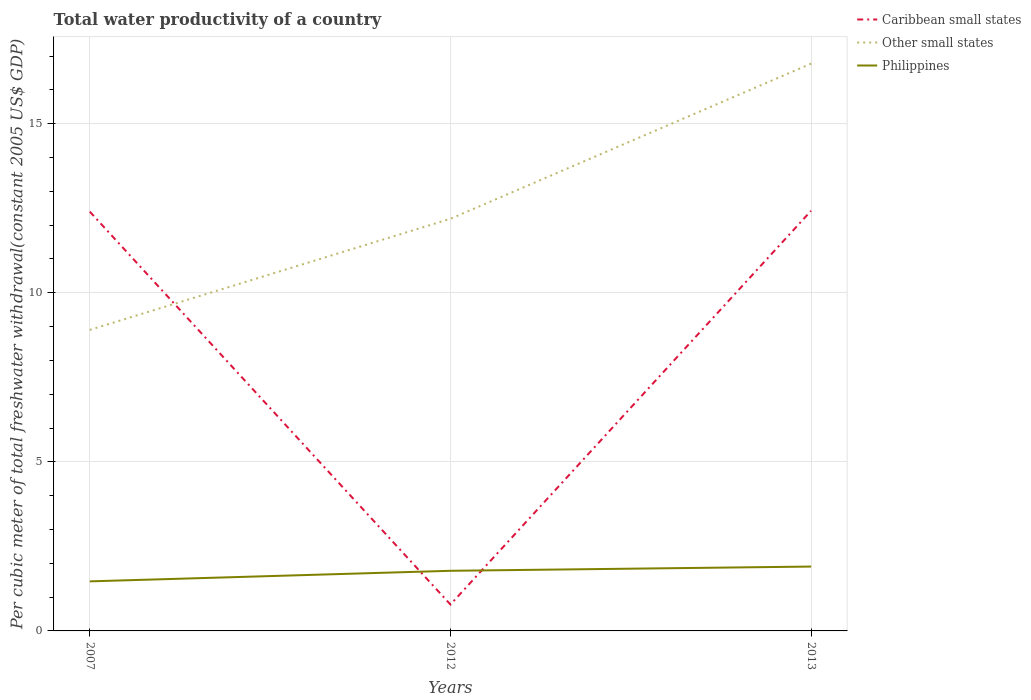How many different coloured lines are there?
Offer a very short reply. 3. Across all years, what is the maximum total water productivity in Other small states?
Your answer should be very brief. 8.9. What is the total total water productivity in Other small states in the graph?
Provide a short and direct response. -4.59. What is the difference between the highest and the second highest total water productivity in Other small states?
Provide a succinct answer. 7.87. Is the total water productivity in Caribbean small states strictly greater than the total water productivity in Philippines over the years?
Your answer should be very brief. No. How many years are there in the graph?
Your response must be concise. 3. Are the values on the major ticks of Y-axis written in scientific E-notation?
Give a very brief answer. No. How many legend labels are there?
Provide a short and direct response. 3. How are the legend labels stacked?
Provide a short and direct response. Vertical. What is the title of the graph?
Keep it short and to the point. Total water productivity of a country. Does "Bahrain" appear as one of the legend labels in the graph?
Your answer should be very brief. No. What is the label or title of the Y-axis?
Your answer should be compact. Per cubic meter of total freshwater withdrawal(constant 2005 US$ GDP). What is the Per cubic meter of total freshwater withdrawal(constant 2005 US$ GDP) in Caribbean small states in 2007?
Give a very brief answer. 12.4. What is the Per cubic meter of total freshwater withdrawal(constant 2005 US$ GDP) in Other small states in 2007?
Your answer should be very brief. 8.9. What is the Per cubic meter of total freshwater withdrawal(constant 2005 US$ GDP) in Philippines in 2007?
Offer a very short reply. 1.47. What is the Per cubic meter of total freshwater withdrawal(constant 2005 US$ GDP) of Caribbean small states in 2012?
Keep it short and to the point. 0.78. What is the Per cubic meter of total freshwater withdrawal(constant 2005 US$ GDP) of Other small states in 2012?
Your response must be concise. 12.19. What is the Per cubic meter of total freshwater withdrawal(constant 2005 US$ GDP) in Philippines in 2012?
Provide a short and direct response. 1.78. What is the Per cubic meter of total freshwater withdrawal(constant 2005 US$ GDP) of Caribbean small states in 2013?
Ensure brevity in your answer.  12.43. What is the Per cubic meter of total freshwater withdrawal(constant 2005 US$ GDP) of Other small states in 2013?
Give a very brief answer. 16.78. What is the Per cubic meter of total freshwater withdrawal(constant 2005 US$ GDP) in Philippines in 2013?
Your answer should be compact. 1.9. Across all years, what is the maximum Per cubic meter of total freshwater withdrawal(constant 2005 US$ GDP) in Caribbean small states?
Ensure brevity in your answer.  12.43. Across all years, what is the maximum Per cubic meter of total freshwater withdrawal(constant 2005 US$ GDP) in Other small states?
Offer a very short reply. 16.78. Across all years, what is the maximum Per cubic meter of total freshwater withdrawal(constant 2005 US$ GDP) in Philippines?
Offer a terse response. 1.9. Across all years, what is the minimum Per cubic meter of total freshwater withdrawal(constant 2005 US$ GDP) of Caribbean small states?
Provide a short and direct response. 0.78. Across all years, what is the minimum Per cubic meter of total freshwater withdrawal(constant 2005 US$ GDP) of Other small states?
Your answer should be very brief. 8.9. Across all years, what is the minimum Per cubic meter of total freshwater withdrawal(constant 2005 US$ GDP) of Philippines?
Make the answer very short. 1.47. What is the total Per cubic meter of total freshwater withdrawal(constant 2005 US$ GDP) of Caribbean small states in the graph?
Provide a short and direct response. 25.61. What is the total Per cubic meter of total freshwater withdrawal(constant 2005 US$ GDP) in Other small states in the graph?
Keep it short and to the point. 37.87. What is the total Per cubic meter of total freshwater withdrawal(constant 2005 US$ GDP) of Philippines in the graph?
Your answer should be compact. 5.15. What is the difference between the Per cubic meter of total freshwater withdrawal(constant 2005 US$ GDP) in Caribbean small states in 2007 and that in 2012?
Make the answer very short. 11.62. What is the difference between the Per cubic meter of total freshwater withdrawal(constant 2005 US$ GDP) of Other small states in 2007 and that in 2012?
Keep it short and to the point. -3.29. What is the difference between the Per cubic meter of total freshwater withdrawal(constant 2005 US$ GDP) of Philippines in 2007 and that in 2012?
Make the answer very short. -0.31. What is the difference between the Per cubic meter of total freshwater withdrawal(constant 2005 US$ GDP) in Caribbean small states in 2007 and that in 2013?
Keep it short and to the point. -0.03. What is the difference between the Per cubic meter of total freshwater withdrawal(constant 2005 US$ GDP) in Other small states in 2007 and that in 2013?
Give a very brief answer. -7.87. What is the difference between the Per cubic meter of total freshwater withdrawal(constant 2005 US$ GDP) in Philippines in 2007 and that in 2013?
Your answer should be very brief. -0.44. What is the difference between the Per cubic meter of total freshwater withdrawal(constant 2005 US$ GDP) in Caribbean small states in 2012 and that in 2013?
Provide a short and direct response. -11.65. What is the difference between the Per cubic meter of total freshwater withdrawal(constant 2005 US$ GDP) in Other small states in 2012 and that in 2013?
Your response must be concise. -4.59. What is the difference between the Per cubic meter of total freshwater withdrawal(constant 2005 US$ GDP) of Philippines in 2012 and that in 2013?
Your response must be concise. -0.13. What is the difference between the Per cubic meter of total freshwater withdrawal(constant 2005 US$ GDP) of Caribbean small states in 2007 and the Per cubic meter of total freshwater withdrawal(constant 2005 US$ GDP) of Other small states in 2012?
Your answer should be very brief. 0.21. What is the difference between the Per cubic meter of total freshwater withdrawal(constant 2005 US$ GDP) in Caribbean small states in 2007 and the Per cubic meter of total freshwater withdrawal(constant 2005 US$ GDP) in Philippines in 2012?
Your answer should be compact. 10.62. What is the difference between the Per cubic meter of total freshwater withdrawal(constant 2005 US$ GDP) of Other small states in 2007 and the Per cubic meter of total freshwater withdrawal(constant 2005 US$ GDP) of Philippines in 2012?
Your response must be concise. 7.12. What is the difference between the Per cubic meter of total freshwater withdrawal(constant 2005 US$ GDP) of Caribbean small states in 2007 and the Per cubic meter of total freshwater withdrawal(constant 2005 US$ GDP) of Other small states in 2013?
Your answer should be very brief. -4.38. What is the difference between the Per cubic meter of total freshwater withdrawal(constant 2005 US$ GDP) of Caribbean small states in 2007 and the Per cubic meter of total freshwater withdrawal(constant 2005 US$ GDP) of Philippines in 2013?
Make the answer very short. 10.5. What is the difference between the Per cubic meter of total freshwater withdrawal(constant 2005 US$ GDP) in Other small states in 2007 and the Per cubic meter of total freshwater withdrawal(constant 2005 US$ GDP) in Philippines in 2013?
Offer a very short reply. 7. What is the difference between the Per cubic meter of total freshwater withdrawal(constant 2005 US$ GDP) in Caribbean small states in 2012 and the Per cubic meter of total freshwater withdrawal(constant 2005 US$ GDP) in Other small states in 2013?
Your answer should be compact. -16. What is the difference between the Per cubic meter of total freshwater withdrawal(constant 2005 US$ GDP) of Caribbean small states in 2012 and the Per cubic meter of total freshwater withdrawal(constant 2005 US$ GDP) of Philippines in 2013?
Your response must be concise. -1.12. What is the difference between the Per cubic meter of total freshwater withdrawal(constant 2005 US$ GDP) of Other small states in 2012 and the Per cubic meter of total freshwater withdrawal(constant 2005 US$ GDP) of Philippines in 2013?
Offer a terse response. 10.29. What is the average Per cubic meter of total freshwater withdrawal(constant 2005 US$ GDP) in Caribbean small states per year?
Your answer should be compact. 8.54. What is the average Per cubic meter of total freshwater withdrawal(constant 2005 US$ GDP) in Other small states per year?
Offer a terse response. 12.62. What is the average Per cubic meter of total freshwater withdrawal(constant 2005 US$ GDP) in Philippines per year?
Your answer should be compact. 1.72. In the year 2007, what is the difference between the Per cubic meter of total freshwater withdrawal(constant 2005 US$ GDP) of Caribbean small states and Per cubic meter of total freshwater withdrawal(constant 2005 US$ GDP) of Other small states?
Your answer should be compact. 3.5. In the year 2007, what is the difference between the Per cubic meter of total freshwater withdrawal(constant 2005 US$ GDP) in Caribbean small states and Per cubic meter of total freshwater withdrawal(constant 2005 US$ GDP) in Philippines?
Provide a short and direct response. 10.93. In the year 2007, what is the difference between the Per cubic meter of total freshwater withdrawal(constant 2005 US$ GDP) in Other small states and Per cubic meter of total freshwater withdrawal(constant 2005 US$ GDP) in Philippines?
Give a very brief answer. 7.44. In the year 2012, what is the difference between the Per cubic meter of total freshwater withdrawal(constant 2005 US$ GDP) in Caribbean small states and Per cubic meter of total freshwater withdrawal(constant 2005 US$ GDP) in Other small states?
Ensure brevity in your answer.  -11.41. In the year 2012, what is the difference between the Per cubic meter of total freshwater withdrawal(constant 2005 US$ GDP) in Caribbean small states and Per cubic meter of total freshwater withdrawal(constant 2005 US$ GDP) in Philippines?
Ensure brevity in your answer.  -1. In the year 2012, what is the difference between the Per cubic meter of total freshwater withdrawal(constant 2005 US$ GDP) of Other small states and Per cubic meter of total freshwater withdrawal(constant 2005 US$ GDP) of Philippines?
Provide a succinct answer. 10.41. In the year 2013, what is the difference between the Per cubic meter of total freshwater withdrawal(constant 2005 US$ GDP) in Caribbean small states and Per cubic meter of total freshwater withdrawal(constant 2005 US$ GDP) in Other small states?
Give a very brief answer. -4.35. In the year 2013, what is the difference between the Per cubic meter of total freshwater withdrawal(constant 2005 US$ GDP) in Caribbean small states and Per cubic meter of total freshwater withdrawal(constant 2005 US$ GDP) in Philippines?
Provide a succinct answer. 10.52. In the year 2013, what is the difference between the Per cubic meter of total freshwater withdrawal(constant 2005 US$ GDP) of Other small states and Per cubic meter of total freshwater withdrawal(constant 2005 US$ GDP) of Philippines?
Make the answer very short. 14.87. What is the ratio of the Per cubic meter of total freshwater withdrawal(constant 2005 US$ GDP) in Caribbean small states in 2007 to that in 2012?
Keep it short and to the point. 15.89. What is the ratio of the Per cubic meter of total freshwater withdrawal(constant 2005 US$ GDP) of Other small states in 2007 to that in 2012?
Your response must be concise. 0.73. What is the ratio of the Per cubic meter of total freshwater withdrawal(constant 2005 US$ GDP) in Philippines in 2007 to that in 2012?
Your answer should be compact. 0.82. What is the ratio of the Per cubic meter of total freshwater withdrawal(constant 2005 US$ GDP) in Caribbean small states in 2007 to that in 2013?
Provide a succinct answer. 1. What is the ratio of the Per cubic meter of total freshwater withdrawal(constant 2005 US$ GDP) in Other small states in 2007 to that in 2013?
Your answer should be compact. 0.53. What is the ratio of the Per cubic meter of total freshwater withdrawal(constant 2005 US$ GDP) in Philippines in 2007 to that in 2013?
Your answer should be compact. 0.77. What is the ratio of the Per cubic meter of total freshwater withdrawal(constant 2005 US$ GDP) in Caribbean small states in 2012 to that in 2013?
Ensure brevity in your answer.  0.06. What is the ratio of the Per cubic meter of total freshwater withdrawal(constant 2005 US$ GDP) of Other small states in 2012 to that in 2013?
Provide a short and direct response. 0.73. What is the ratio of the Per cubic meter of total freshwater withdrawal(constant 2005 US$ GDP) of Philippines in 2012 to that in 2013?
Your answer should be very brief. 0.93. What is the difference between the highest and the second highest Per cubic meter of total freshwater withdrawal(constant 2005 US$ GDP) in Caribbean small states?
Make the answer very short. 0.03. What is the difference between the highest and the second highest Per cubic meter of total freshwater withdrawal(constant 2005 US$ GDP) of Other small states?
Provide a short and direct response. 4.59. What is the difference between the highest and the second highest Per cubic meter of total freshwater withdrawal(constant 2005 US$ GDP) of Philippines?
Your answer should be very brief. 0.13. What is the difference between the highest and the lowest Per cubic meter of total freshwater withdrawal(constant 2005 US$ GDP) of Caribbean small states?
Provide a short and direct response. 11.65. What is the difference between the highest and the lowest Per cubic meter of total freshwater withdrawal(constant 2005 US$ GDP) of Other small states?
Your answer should be very brief. 7.87. What is the difference between the highest and the lowest Per cubic meter of total freshwater withdrawal(constant 2005 US$ GDP) of Philippines?
Your answer should be very brief. 0.44. 